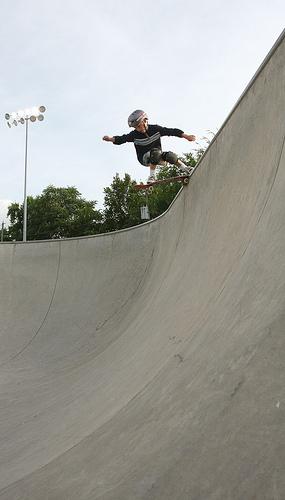What this boy doing with skateboard?
Answer briefly. Skating. Are the lights on?
Write a very short answer. No. What color is the ramp?
Answer briefly. Gray. 